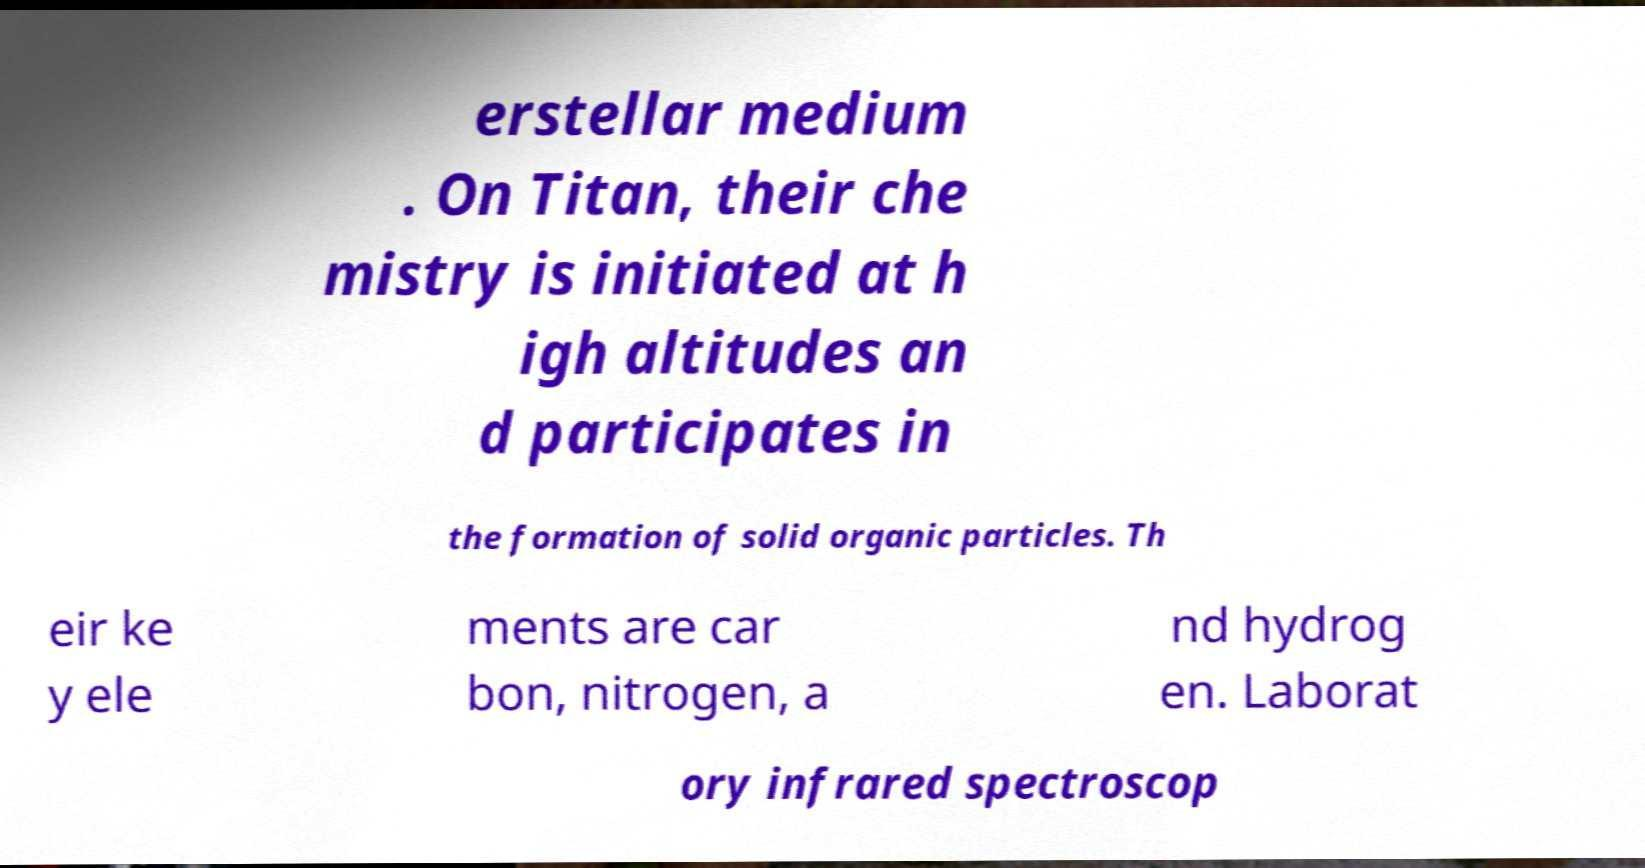Can you accurately transcribe the text from the provided image for me? erstellar medium . On Titan, their che mistry is initiated at h igh altitudes an d participates in the formation of solid organic particles. Th eir ke y ele ments are car bon, nitrogen, a nd hydrog en. Laborat ory infrared spectroscop 